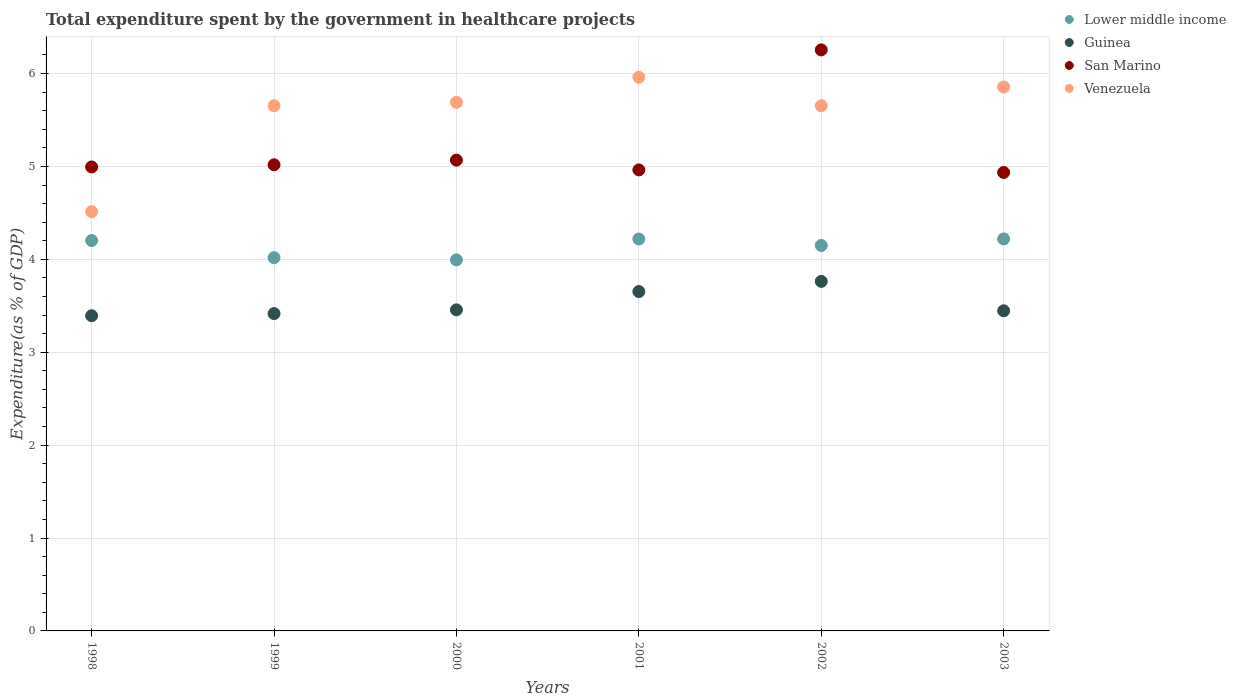How many different coloured dotlines are there?
Provide a succinct answer. 4. What is the total expenditure spent by the government in healthcare projects in Lower middle income in 1999?
Keep it short and to the point. 4.02. Across all years, what is the maximum total expenditure spent by the government in healthcare projects in Venezuela?
Give a very brief answer. 5.96. Across all years, what is the minimum total expenditure spent by the government in healthcare projects in Venezuela?
Your answer should be very brief. 4.51. In which year was the total expenditure spent by the government in healthcare projects in Lower middle income maximum?
Your answer should be compact. 2003. In which year was the total expenditure spent by the government in healthcare projects in San Marino minimum?
Provide a short and direct response. 2003. What is the total total expenditure spent by the government in healthcare projects in Guinea in the graph?
Keep it short and to the point. 21.13. What is the difference between the total expenditure spent by the government in healthcare projects in San Marino in 2001 and that in 2003?
Your answer should be compact. 0.03. What is the difference between the total expenditure spent by the government in healthcare projects in Venezuela in 1998 and the total expenditure spent by the government in healthcare projects in San Marino in 2001?
Offer a very short reply. -0.45. What is the average total expenditure spent by the government in healthcare projects in Lower middle income per year?
Provide a short and direct response. 4.13. In the year 2001, what is the difference between the total expenditure spent by the government in healthcare projects in San Marino and total expenditure spent by the government in healthcare projects in Venezuela?
Provide a short and direct response. -1. What is the ratio of the total expenditure spent by the government in healthcare projects in Guinea in 2002 to that in 2003?
Provide a succinct answer. 1.09. What is the difference between the highest and the second highest total expenditure spent by the government in healthcare projects in Venezuela?
Offer a terse response. 0.1. What is the difference between the highest and the lowest total expenditure spent by the government in healthcare projects in San Marino?
Provide a succinct answer. 1.32. Is it the case that in every year, the sum of the total expenditure spent by the government in healthcare projects in Lower middle income and total expenditure spent by the government in healthcare projects in Venezuela  is greater than the sum of total expenditure spent by the government in healthcare projects in Guinea and total expenditure spent by the government in healthcare projects in San Marino?
Your answer should be very brief. No. Does the total expenditure spent by the government in healthcare projects in San Marino monotonically increase over the years?
Ensure brevity in your answer.  No. Are the values on the major ticks of Y-axis written in scientific E-notation?
Give a very brief answer. No. How are the legend labels stacked?
Your response must be concise. Vertical. What is the title of the graph?
Ensure brevity in your answer.  Total expenditure spent by the government in healthcare projects. What is the label or title of the Y-axis?
Ensure brevity in your answer.  Expenditure(as % of GDP). What is the Expenditure(as % of GDP) of Lower middle income in 1998?
Offer a terse response. 4.2. What is the Expenditure(as % of GDP) of Guinea in 1998?
Your answer should be very brief. 3.39. What is the Expenditure(as % of GDP) of San Marino in 1998?
Your answer should be very brief. 4.99. What is the Expenditure(as % of GDP) in Venezuela in 1998?
Give a very brief answer. 4.51. What is the Expenditure(as % of GDP) in Lower middle income in 1999?
Keep it short and to the point. 4.02. What is the Expenditure(as % of GDP) of Guinea in 1999?
Keep it short and to the point. 3.42. What is the Expenditure(as % of GDP) in San Marino in 1999?
Your answer should be compact. 5.02. What is the Expenditure(as % of GDP) of Venezuela in 1999?
Keep it short and to the point. 5.65. What is the Expenditure(as % of GDP) of Lower middle income in 2000?
Offer a terse response. 3.99. What is the Expenditure(as % of GDP) of Guinea in 2000?
Provide a short and direct response. 3.46. What is the Expenditure(as % of GDP) of San Marino in 2000?
Your response must be concise. 5.07. What is the Expenditure(as % of GDP) in Venezuela in 2000?
Your answer should be very brief. 5.69. What is the Expenditure(as % of GDP) of Lower middle income in 2001?
Offer a terse response. 4.22. What is the Expenditure(as % of GDP) in Guinea in 2001?
Make the answer very short. 3.65. What is the Expenditure(as % of GDP) in San Marino in 2001?
Give a very brief answer. 4.96. What is the Expenditure(as % of GDP) of Venezuela in 2001?
Keep it short and to the point. 5.96. What is the Expenditure(as % of GDP) in Lower middle income in 2002?
Your answer should be very brief. 4.15. What is the Expenditure(as % of GDP) of Guinea in 2002?
Provide a short and direct response. 3.76. What is the Expenditure(as % of GDP) of San Marino in 2002?
Give a very brief answer. 6.25. What is the Expenditure(as % of GDP) of Venezuela in 2002?
Make the answer very short. 5.65. What is the Expenditure(as % of GDP) in Lower middle income in 2003?
Your answer should be very brief. 4.22. What is the Expenditure(as % of GDP) in Guinea in 2003?
Provide a succinct answer. 3.45. What is the Expenditure(as % of GDP) in San Marino in 2003?
Your answer should be compact. 4.94. What is the Expenditure(as % of GDP) in Venezuela in 2003?
Your answer should be compact. 5.86. Across all years, what is the maximum Expenditure(as % of GDP) in Lower middle income?
Ensure brevity in your answer.  4.22. Across all years, what is the maximum Expenditure(as % of GDP) of Guinea?
Offer a terse response. 3.76. Across all years, what is the maximum Expenditure(as % of GDP) of San Marino?
Provide a succinct answer. 6.25. Across all years, what is the maximum Expenditure(as % of GDP) in Venezuela?
Make the answer very short. 5.96. Across all years, what is the minimum Expenditure(as % of GDP) in Lower middle income?
Your answer should be very brief. 3.99. Across all years, what is the minimum Expenditure(as % of GDP) in Guinea?
Provide a succinct answer. 3.39. Across all years, what is the minimum Expenditure(as % of GDP) of San Marino?
Offer a terse response. 4.94. Across all years, what is the minimum Expenditure(as % of GDP) in Venezuela?
Offer a terse response. 4.51. What is the total Expenditure(as % of GDP) of Lower middle income in the graph?
Keep it short and to the point. 24.8. What is the total Expenditure(as % of GDP) in Guinea in the graph?
Your answer should be compact. 21.13. What is the total Expenditure(as % of GDP) in San Marino in the graph?
Ensure brevity in your answer.  31.23. What is the total Expenditure(as % of GDP) of Venezuela in the graph?
Offer a terse response. 33.33. What is the difference between the Expenditure(as % of GDP) in Lower middle income in 1998 and that in 1999?
Offer a very short reply. 0.18. What is the difference between the Expenditure(as % of GDP) in Guinea in 1998 and that in 1999?
Give a very brief answer. -0.02. What is the difference between the Expenditure(as % of GDP) of San Marino in 1998 and that in 1999?
Your response must be concise. -0.02. What is the difference between the Expenditure(as % of GDP) of Venezuela in 1998 and that in 1999?
Keep it short and to the point. -1.14. What is the difference between the Expenditure(as % of GDP) of Lower middle income in 1998 and that in 2000?
Make the answer very short. 0.21. What is the difference between the Expenditure(as % of GDP) in Guinea in 1998 and that in 2000?
Give a very brief answer. -0.06. What is the difference between the Expenditure(as % of GDP) in San Marino in 1998 and that in 2000?
Your answer should be compact. -0.07. What is the difference between the Expenditure(as % of GDP) of Venezuela in 1998 and that in 2000?
Make the answer very short. -1.18. What is the difference between the Expenditure(as % of GDP) in Lower middle income in 1998 and that in 2001?
Your response must be concise. -0.02. What is the difference between the Expenditure(as % of GDP) in Guinea in 1998 and that in 2001?
Your answer should be very brief. -0.26. What is the difference between the Expenditure(as % of GDP) in San Marino in 1998 and that in 2001?
Provide a succinct answer. 0.03. What is the difference between the Expenditure(as % of GDP) of Venezuela in 1998 and that in 2001?
Provide a short and direct response. -1.45. What is the difference between the Expenditure(as % of GDP) of Lower middle income in 1998 and that in 2002?
Ensure brevity in your answer.  0.05. What is the difference between the Expenditure(as % of GDP) in Guinea in 1998 and that in 2002?
Offer a terse response. -0.37. What is the difference between the Expenditure(as % of GDP) in San Marino in 1998 and that in 2002?
Your response must be concise. -1.26. What is the difference between the Expenditure(as % of GDP) of Venezuela in 1998 and that in 2002?
Your answer should be very brief. -1.14. What is the difference between the Expenditure(as % of GDP) of Lower middle income in 1998 and that in 2003?
Your response must be concise. -0.02. What is the difference between the Expenditure(as % of GDP) in Guinea in 1998 and that in 2003?
Make the answer very short. -0.05. What is the difference between the Expenditure(as % of GDP) of San Marino in 1998 and that in 2003?
Give a very brief answer. 0.06. What is the difference between the Expenditure(as % of GDP) in Venezuela in 1998 and that in 2003?
Offer a terse response. -1.34. What is the difference between the Expenditure(as % of GDP) in Lower middle income in 1999 and that in 2000?
Offer a very short reply. 0.02. What is the difference between the Expenditure(as % of GDP) of Guinea in 1999 and that in 2000?
Your answer should be compact. -0.04. What is the difference between the Expenditure(as % of GDP) in San Marino in 1999 and that in 2000?
Make the answer very short. -0.05. What is the difference between the Expenditure(as % of GDP) of Venezuela in 1999 and that in 2000?
Provide a succinct answer. -0.04. What is the difference between the Expenditure(as % of GDP) of Lower middle income in 1999 and that in 2001?
Offer a terse response. -0.2. What is the difference between the Expenditure(as % of GDP) of Guinea in 1999 and that in 2001?
Provide a succinct answer. -0.24. What is the difference between the Expenditure(as % of GDP) of San Marino in 1999 and that in 2001?
Offer a very short reply. 0.06. What is the difference between the Expenditure(as % of GDP) of Venezuela in 1999 and that in 2001?
Keep it short and to the point. -0.31. What is the difference between the Expenditure(as % of GDP) of Lower middle income in 1999 and that in 2002?
Give a very brief answer. -0.13. What is the difference between the Expenditure(as % of GDP) in Guinea in 1999 and that in 2002?
Offer a very short reply. -0.35. What is the difference between the Expenditure(as % of GDP) in San Marino in 1999 and that in 2002?
Give a very brief answer. -1.24. What is the difference between the Expenditure(as % of GDP) of Venezuela in 1999 and that in 2002?
Ensure brevity in your answer.  -0. What is the difference between the Expenditure(as % of GDP) of Lower middle income in 1999 and that in 2003?
Provide a succinct answer. -0.2. What is the difference between the Expenditure(as % of GDP) of Guinea in 1999 and that in 2003?
Make the answer very short. -0.03. What is the difference between the Expenditure(as % of GDP) of San Marino in 1999 and that in 2003?
Your answer should be compact. 0.08. What is the difference between the Expenditure(as % of GDP) in Venezuela in 1999 and that in 2003?
Provide a short and direct response. -0.2. What is the difference between the Expenditure(as % of GDP) of Lower middle income in 2000 and that in 2001?
Provide a short and direct response. -0.23. What is the difference between the Expenditure(as % of GDP) of Guinea in 2000 and that in 2001?
Your answer should be compact. -0.2. What is the difference between the Expenditure(as % of GDP) in San Marino in 2000 and that in 2001?
Provide a short and direct response. 0.11. What is the difference between the Expenditure(as % of GDP) in Venezuela in 2000 and that in 2001?
Offer a terse response. -0.27. What is the difference between the Expenditure(as % of GDP) of Lower middle income in 2000 and that in 2002?
Offer a terse response. -0.16. What is the difference between the Expenditure(as % of GDP) in Guinea in 2000 and that in 2002?
Your response must be concise. -0.31. What is the difference between the Expenditure(as % of GDP) of San Marino in 2000 and that in 2002?
Provide a succinct answer. -1.19. What is the difference between the Expenditure(as % of GDP) in Venezuela in 2000 and that in 2002?
Your answer should be very brief. 0.04. What is the difference between the Expenditure(as % of GDP) of Lower middle income in 2000 and that in 2003?
Make the answer very short. -0.23. What is the difference between the Expenditure(as % of GDP) in Guinea in 2000 and that in 2003?
Give a very brief answer. 0.01. What is the difference between the Expenditure(as % of GDP) of San Marino in 2000 and that in 2003?
Make the answer very short. 0.13. What is the difference between the Expenditure(as % of GDP) in Venezuela in 2000 and that in 2003?
Your response must be concise. -0.16. What is the difference between the Expenditure(as % of GDP) in Lower middle income in 2001 and that in 2002?
Offer a terse response. 0.07. What is the difference between the Expenditure(as % of GDP) of Guinea in 2001 and that in 2002?
Your answer should be very brief. -0.11. What is the difference between the Expenditure(as % of GDP) in San Marino in 2001 and that in 2002?
Your answer should be very brief. -1.29. What is the difference between the Expenditure(as % of GDP) in Venezuela in 2001 and that in 2002?
Offer a very short reply. 0.31. What is the difference between the Expenditure(as % of GDP) of Lower middle income in 2001 and that in 2003?
Provide a short and direct response. -0. What is the difference between the Expenditure(as % of GDP) of Guinea in 2001 and that in 2003?
Your answer should be compact. 0.21. What is the difference between the Expenditure(as % of GDP) of San Marino in 2001 and that in 2003?
Ensure brevity in your answer.  0.03. What is the difference between the Expenditure(as % of GDP) of Venezuela in 2001 and that in 2003?
Provide a succinct answer. 0.1. What is the difference between the Expenditure(as % of GDP) in Lower middle income in 2002 and that in 2003?
Provide a succinct answer. -0.07. What is the difference between the Expenditure(as % of GDP) in Guinea in 2002 and that in 2003?
Provide a succinct answer. 0.32. What is the difference between the Expenditure(as % of GDP) of San Marino in 2002 and that in 2003?
Give a very brief answer. 1.32. What is the difference between the Expenditure(as % of GDP) in Venezuela in 2002 and that in 2003?
Provide a succinct answer. -0.2. What is the difference between the Expenditure(as % of GDP) in Lower middle income in 1998 and the Expenditure(as % of GDP) in Guinea in 1999?
Give a very brief answer. 0.79. What is the difference between the Expenditure(as % of GDP) in Lower middle income in 1998 and the Expenditure(as % of GDP) in San Marino in 1999?
Make the answer very short. -0.82. What is the difference between the Expenditure(as % of GDP) in Lower middle income in 1998 and the Expenditure(as % of GDP) in Venezuela in 1999?
Your response must be concise. -1.45. What is the difference between the Expenditure(as % of GDP) in Guinea in 1998 and the Expenditure(as % of GDP) in San Marino in 1999?
Provide a succinct answer. -1.62. What is the difference between the Expenditure(as % of GDP) of Guinea in 1998 and the Expenditure(as % of GDP) of Venezuela in 1999?
Offer a terse response. -2.26. What is the difference between the Expenditure(as % of GDP) of San Marino in 1998 and the Expenditure(as % of GDP) of Venezuela in 1999?
Offer a terse response. -0.66. What is the difference between the Expenditure(as % of GDP) in Lower middle income in 1998 and the Expenditure(as % of GDP) in Guinea in 2000?
Your response must be concise. 0.75. What is the difference between the Expenditure(as % of GDP) in Lower middle income in 1998 and the Expenditure(as % of GDP) in San Marino in 2000?
Your response must be concise. -0.87. What is the difference between the Expenditure(as % of GDP) in Lower middle income in 1998 and the Expenditure(as % of GDP) in Venezuela in 2000?
Keep it short and to the point. -1.49. What is the difference between the Expenditure(as % of GDP) of Guinea in 1998 and the Expenditure(as % of GDP) of San Marino in 2000?
Ensure brevity in your answer.  -1.68. What is the difference between the Expenditure(as % of GDP) of Guinea in 1998 and the Expenditure(as % of GDP) of Venezuela in 2000?
Provide a succinct answer. -2.3. What is the difference between the Expenditure(as % of GDP) of San Marino in 1998 and the Expenditure(as % of GDP) of Venezuela in 2000?
Your answer should be compact. -0.7. What is the difference between the Expenditure(as % of GDP) of Lower middle income in 1998 and the Expenditure(as % of GDP) of Guinea in 2001?
Give a very brief answer. 0.55. What is the difference between the Expenditure(as % of GDP) of Lower middle income in 1998 and the Expenditure(as % of GDP) of San Marino in 2001?
Offer a very short reply. -0.76. What is the difference between the Expenditure(as % of GDP) in Lower middle income in 1998 and the Expenditure(as % of GDP) in Venezuela in 2001?
Your answer should be very brief. -1.76. What is the difference between the Expenditure(as % of GDP) of Guinea in 1998 and the Expenditure(as % of GDP) of San Marino in 2001?
Make the answer very short. -1.57. What is the difference between the Expenditure(as % of GDP) in Guinea in 1998 and the Expenditure(as % of GDP) in Venezuela in 2001?
Make the answer very short. -2.57. What is the difference between the Expenditure(as % of GDP) of San Marino in 1998 and the Expenditure(as % of GDP) of Venezuela in 2001?
Ensure brevity in your answer.  -0.97. What is the difference between the Expenditure(as % of GDP) in Lower middle income in 1998 and the Expenditure(as % of GDP) in Guinea in 2002?
Give a very brief answer. 0.44. What is the difference between the Expenditure(as % of GDP) of Lower middle income in 1998 and the Expenditure(as % of GDP) of San Marino in 2002?
Keep it short and to the point. -2.05. What is the difference between the Expenditure(as % of GDP) of Lower middle income in 1998 and the Expenditure(as % of GDP) of Venezuela in 2002?
Ensure brevity in your answer.  -1.45. What is the difference between the Expenditure(as % of GDP) of Guinea in 1998 and the Expenditure(as % of GDP) of San Marino in 2002?
Make the answer very short. -2.86. What is the difference between the Expenditure(as % of GDP) of Guinea in 1998 and the Expenditure(as % of GDP) of Venezuela in 2002?
Offer a very short reply. -2.26. What is the difference between the Expenditure(as % of GDP) in San Marino in 1998 and the Expenditure(as % of GDP) in Venezuela in 2002?
Provide a short and direct response. -0.66. What is the difference between the Expenditure(as % of GDP) of Lower middle income in 1998 and the Expenditure(as % of GDP) of Guinea in 2003?
Keep it short and to the point. 0.76. What is the difference between the Expenditure(as % of GDP) of Lower middle income in 1998 and the Expenditure(as % of GDP) of San Marino in 2003?
Your answer should be very brief. -0.73. What is the difference between the Expenditure(as % of GDP) of Lower middle income in 1998 and the Expenditure(as % of GDP) of Venezuela in 2003?
Your answer should be very brief. -1.65. What is the difference between the Expenditure(as % of GDP) in Guinea in 1998 and the Expenditure(as % of GDP) in San Marino in 2003?
Make the answer very short. -1.54. What is the difference between the Expenditure(as % of GDP) in Guinea in 1998 and the Expenditure(as % of GDP) in Venezuela in 2003?
Provide a succinct answer. -2.46. What is the difference between the Expenditure(as % of GDP) in San Marino in 1998 and the Expenditure(as % of GDP) in Venezuela in 2003?
Keep it short and to the point. -0.86. What is the difference between the Expenditure(as % of GDP) in Lower middle income in 1999 and the Expenditure(as % of GDP) in Guinea in 2000?
Your answer should be compact. 0.56. What is the difference between the Expenditure(as % of GDP) in Lower middle income in 1999 and the Expenditure(as % of GDP) in San Marino in 2000?
Your answer should be compact. -1.05. What is the difference between the Expenditure(as % of GDP) of Lower middle income in 1999 and the Expenditure(as % of GDP) of Venezuela in 2000?
Your response must be concise. -1.67. What is the difference between the Expenditure(as % of GDP) of Guinea in 1999 and the Expenditure(as % of GDP) of San Marino in 2000?
Your response must be concise. -1.65. What is the difference between the Expenditure(as % of GDP) of Guinea in 1999 and the Expenditure(as % of GDP) of Venezuela in 2000?
Ensure brevity in your answer.  -2.27. What is the difference between the Expenditure(as % of GDP) in San Marino in 1999 and the Expenditure(as % of GDP) in Venezuela in 2000?
Offer a very short reply. -0.67. What is the difference between the Expenditure(as % of GDP) of Lower middle income in 1999 and the Expenditure(as % of GDP) of Guinea in 2001?
Your response must be concise. 0.36. What is the difference between the Expenditure(as % of GDP) in Lower middle income in 1999 and the Expenditure(as % of GDP) in San Marino in 2001?
Keep it short and to the point. -0.94. What is the difference between the Expenditure(as % of GDP) of Lower middle income in 1999 and the Expenditure(as % of GDP) of Venezuela in 2001?
Provide a succinct answer. -1.94. What is the difference between the Expenditure(as % of GDP) in Guinea in 1999 and the Expenditure(as % of GDP) in San Marino in 2001?
Your answer should be compact. -1.55. What is the difference between the Expenditure(as % of GDP) of Guinea in 1999 and the Expenditure(as % of GDP) of Venezuela in 2001?
Offer a terse response. -2.54. What is the difference between the Expenditure(as % of GDP) in San Marino in 1999 and the Expenditure(as % of GDP) in Venezuela in 2001?
Offer a very short reply. -0.94. What is the difference between the Expenditure(as % of GDP) of Lower middle income in 1999 and the Expenditure(as % of GDP) of Guinea in 2002?
Keep it short and to the point. 0.26. What is the difference between the Expenditure(as % of GDP) of Lower middle income in 1999 and the Expenditure(as % of GDP) of San Marino in 2002?
Your answer should be compact. -2.24. What is the difference between the Expenditure(as % of GDP) of Lower middle income in 1999 and the Expenditure(as % of GDP) of Venezuela in 2002?
Provide a short and direct response. -1.64. What is the difference between the Expenditure(as % of GDP) of Guinea in 1999 and the Expenditure(as % of GDP) of San Marino in 2002?
Your response must be concise. -2.84. What is the difference between the Expenditure(as % of GDP) of Guinea in 1999 and the Expenditure(as % of GDP) of Venezuela in 2002?
Offer a very short reply. -2.24. What is the difference between the Expenditure(as % of GDP) in San Marino in 1999 and the Expenditure(as % of GDP) in Venezuela in 2002?
Your response must be concise. -0.64. What is the difference between the Expenditure(as % of GDP) of Lower middle income in 1999 and the Expenditure(as % of GDP) of Guinea in 2003?
Your answer should be compact. 0.57. What is the difference between the Expenditure(as % of GDP) of Lower middle income in 1999 and the Expenditure(as % of GDP) of San Marino in 2003?
Make the answer very short. -0.92. What is the difference between the Expenditure(as % of GDP) in Lower middle income in 1999 and the Expenditure(as % of GDP) in Venezuela in 2003?
Provide a short and direct response. -1.84. What is the difference between the Expenditure(as % of GDP) in Guinea in 1999 and the Expenditure(as % of GDP) in San Marino in 2003?
Keep it short and to the point. -1.52. What is the difference between the Expenditure(as % of GDP) in Guinea in 1999 and the Expenditure(as % of GDP) in Venezuela in 2003?
Your answer should be compact. -2.44. What is the difference between the Expenditure(as % of GDP) of San Marino in 1999 and the Expenditure(as % of GDP) of Venezuela in 2003?
Provide a succinct answer. -0.84. What is the difference between the Expenditure(as % of GDP) of Lower middle income in 2000 and the Expenditure(as % of GDP) of Guinea in 2001?
Offer a terse response. 0.34. What is the difference between the Expenditure(as % of GDP) in Lower middle income in 2000 and the Expenditure(as % of GDP) in San Marino in 2001?
Your response must be concise. -0.97. What is the difference between the Expenditure(as % of GDP) in Lower middle income in 2000 and the Expenditure(as % of GDP) in Venezuela in 2001?
Give a very brief answer. -1.97. What is the difference between the Expenditure(as % of GDP) in Guinea in 2000 and the Expenditure(as % of GDP) in San Marino in 2001?
Your response must be concise. -1.51. What is the difference between the Expenditure(as % of GDP) in Guinea in 2000 and the Expenditure(as % of GDP) in Venezuela in 2001?
Your answer should be compact. -2.5. What is the difference between the Expenditure(as % of GDP) in San Marino in 2000 and the Expenditure(as % of GDP) in Venezuela in 2001?
Offer a terse response. -0.89. What is the difference between the Expenditure(as % of GDP) in Lower middle income in 2000 and the Expenditure(as % of GDP) in Guinea in 2002?
Your answer should be very brief. 0.23. What is the difference between the Expenditure(as % of GDP) of Lower middle income in 2000 and the Expenditure(as % of GDP) of San Marino in 2002?
Offer a terse response. -2.26. What is the difference between the Expenditure(as % of GDP) in Lower middle income in 2000 and the Expenditure(as % of GDP) in Venezuela in 2002?
Your answer should be compact. -1.66. What is the difference between the Expenditure(as % of GDP) of Guinea in 2000 and the Expenditure(as % of GDP) of San Marino in 2002?
Provide a succinct answer. -2.8. What is the difference between the Expenditure(as % of GDP) in Guinea in 2000 and the Expenditure(as % of GDP) in Venezuela in 2002?
Make the answer very short. -2.2. What is the difference between the Expenditure(as % of GDP) of San Marino in 2000 and the Expenditure(as % of GDP) of Venezuela in 2002?
Your answer should be very brief. -0.59. What is the difference between the Expenditure(as % of GDP) in Lower middle income in 2000 and the Expenditure(as % of GDP) in Guinea in 2003?
Offer a terse response. 0.55. What is the difference between the Expenditure(as % of GDP) of Lower middle income in 2000 and the Expenditure(as % of GDP) of San Marino in 2003?
Make the answer very short. -0.94. What is the difference between the Expenditure(as % of GDP) in Lower middle income in 2000 and the Expenditure(as % of GDP) in Venezuela in 2003?
Ensure brevity in your answer.  -1.86. What is the difference between the Expenditure(as % of GDP) of Guinea in 2000 and the Expenditure(as % of GDP) of San Marino in 2003?
Provide a succinct answer. -1.48. What is the difference between the Expenditure(as % of GDP) of Guinea in 2000 and the Expenditure(as % of GDP) of Venezuela in 2003?
Ensure brevity in your answer.  -2.4. What is the difference between the Expenditure(as % of GDP) of San Marino in 2000 and the Expenditure(as % of GDP) of Venezuela in 2003?
Offer a terse response. -0.79. What is the difference between the Expenditure(as % of GDP) of Lower middle income in 2001 and the Expenditure(as % of GDP) of Guinea in 2002?
Provide a succinct answer. 0.46. What is the difference between the Expenditure(as % of GDP) of Lower middle income in 2001 and the Expenditure(as % of GDP) of San Marino in 2002?
Ensure brevity in your answer.  -2.04. What is the difference between the Expenditure(as % of GDP) of Lower middle income in 2001 and the Expenditure(as % of GDP) of Venezuela in 2002?
Ensure brevity in your answer.  -1.43. What is the difference between the Expenditure(as % of GDP) in Guinea in 2001 and the Expenditure(as % of GDP) in San Marino in 2002?
Your answer should be compact. -2.6. What is the difference between the Expenditure(as % of GDP) in Guinea in 2001 and the Expenditure(as % of GDP) in Venezuela in 2002?
Give a very brief answer. -2. What is the difference between the Expenditure(as % of GDP) in San Marino in 2001 and the Expenditure(as % of GDP) in Venezuela in 2002?
Provide a succinct answer. -0.69. What is the difference between the Expenditure(as % of GDP) of Lower middle income in 2001 and the Expenditure(as % of GDP) of Guinea in 2003?
Make the answer very short. 0.77. What is the difference between the Expenditure(as % of GDP) of Lower middle income in 2001 and the Expenditure(as % of GDP) of San Marino in 2003?
Give a very brief answer. -0.72. What is the difference between the Expenditure(as % of GDP) in Lower middle income in 2001 and the Expenditure(as % of GDP) in Venezuela in 2003?
Make the answer very short. -1.64. What is the difference between the Expenditure(as % of GDP) in Guinea in 2001 and the Expenditure(as % of GDP) in San Marino in 2003?
Offer a very short reply. -1.28. What is the difference between the Expenditure(as % of GDP) of Guinea in 2001 and the Expenditure(as % of GDP) of Venezuela in 2003?
Your answer should be compact. -2.2. What is the difference between the Expenditure(as % of GDP) of San Marino in 2001 and the Expenditure(as % of GDP) of Venezuela in 2003?
Offer a terse response. -0.89. What is the difference between the Expenditure(as % of GDP) in Lower middle income in 2002 and the Expenditure(as % of GDP) in Guinea in 2003?
Ensure brevity in your answer.  0.7. What is the difference between the Expenditure(as % of GDP) of Lower middle income in 2002 and the Expenditure(as % of GDP) of San Marino in 2003?
Ensure brevity in your answer.  -0.79. What is the difference between the Expenditure(as % of GDP) of Lower middle income in 2002 and the Expenditure(as % of GDP) of Venezuela in 2003?
Your answer should be very brief. -1.71. What is the difference between the Expenditure(as % of GDP) in Guinea in 2002 and the Expenditure(as % of GDP) in San Marino in 2003?
Offer a terse response. -1.17. What is the difference between the Expenditure(as % of GDP) of Guinea in 2002 and the Expenditure(as % of GDP) of Venezuela in 2003?
Make the answer very short. -2.09. What is the difference between the Expenditure(as % of GDP) in San Marino in 2002 and the Expenditure(as % of GDP) in Venezuela in 2003?
Provide a short and direct response. 0.4. What is the average Expenditure(as % of GDP) of Lower middle income per year?
Provide a succinct answer. 4.13. What is the average Expenditure(as % of GDP) in Guinea per year?
Your response must be concise. 3.52. What is the average Expenditure(as % of GDP) of San Marino per year?
Ensure brevity in your answer.  5.21. What is the average Expenditure(as % of GDP) in Venezuela per year?
Offer a very short reply. 5.55. In the year 1998, what is the difference between the Expenditure(as % of GDP) in Lower middle income and Expenditure(as % of GDP) in Guinea?
Your answer should be very brief. 0.81. In the year 1998, what is the difference between the Expenditure(as % of GDP) in Lower middle income and Expenditure(as % of GDP) in San Marino?
Your response must be concise. -0.79. In the year 1998, what is the difference between the Expenditure(as % of GDP) of Lower middle income and Expenditure(as % of GDP) of Venezuela?
Give a very brief answer. -0.31. In the year 1998, what is the difference between the Expenditure(as % of GDP) in Guinea and Expenditure(as % of GDP) in San Marino?
Provide a short and direct response. -1.6. In the year 1998, what is the difference between the Expenditure(as % of GDP) in Guinea and Expenditure(as % of GDP) in Venezuela?
Provide a succinct answer. -1.12. In the year 1998, what is the difference between the Expenditure(as % of GDP) in San Marino and Expenditure(as % of GDP) in Venezuela?
Make the answer very short. 0.48. In the year 1999, what is the difference between the Expenditure(as % of GDP) of Lower middle income and Expenditure(as % of GDP) of Guinea?
Your answer should be very brief. 0.6. In the year 1999, what is the difference between the Expenditure(as % of GDP) of Lower middle income and Expenditure(as % of GDP) of San Marino?
Your response must be concise. -1. In the year 1999, what is the difference between the Expenditure(as % of GDP) in Lower middle income and Expenditure(as % of GDP) in Venezuela?
Keep it short and to the point. -1.64. In the year 1999, what is the difference between the Expenditure(as % of GDP) of Guinea and Expenditure(as % of GDP) of San Marino?
Ensure brevity in your answer.  -1.6. In the year 1999, what is the difference between the Expenditure(as % of GDP) in Guinea and Expenditure(as % of GDP) in Venezuela?
Make the answer very short. -2.24. In the year 1999, what is the difference between the Expenditure(as % of GDP) in San Marino and Expenditure(as % of GDP) in Venezuela?
Your answer should be very brief. -0.64. In the year 2000, what is the difference between the Expenditure(as % of GDP) in Lower middle income and Expenditure(as % of GDP) in Guinea?
Offer a very short reply. 0.54. In the year 2000, what is the difference between the Expenditure(as % of GDP) of Lower middle income and Expenditure(as % of GDP) of San Marino?
Keep it short and to the point. -1.07. In the year 2000, what is the difference between the Expenditure(as % of GDP) in Lower middle income and Expenditure(as % of GDP) in Venezuela?
Your response must be concise. -1.7. In the year 2000, what is the difference between the Expenditure(as % of GDP) in Guinea and Expenditure(as % of GDP) in San Marino?
Offer a terse response. -1.61. In the year 2000, what is the difference between the Expenditure(as % of GDP) in Guinea and Expenditure(as % of GDP) in Venezuela?
Provide a short and direct response. -2.23. In the year 2000, what is the difference between the Expenditure(as % of GDP) of San Marino and Expenditure(as % of GDP) of Venezuela?
Make the answer very short. -0.62. In the year 2001, what is the difference between the Expenditure(as % of GDP) in Lower middle income and Expenditure(as % of GDP) in Guinea?
Your answer should be very brief. 0.57. In the year 2001, what is the difference between the Expenditure(as % of GDP) of Lower middle income and Expenditure(as % of GDP) of San Marino?
Your response must be concise. -0.74. In the year 2001, what is the difference between the Expenditure(as % of GDP) in Lower middle income and Expenditure(as % of GDP) in Venezuela?
Make the answer very short. -1.74. In the year 2001, what is the difference between the Expenditure(as % of GDP) of Guinea and Expenditure(as % of GDP) of San Marino?
Give a very brief answer. -1.31. In the year 2001, what is the difference between the Expenditure(as % of GDP) of Guinea and Expenditure(as % of GDP) of Venezuela?
Make the answer very short. -2.31. In the year 2001, what is the difference between the Expenditure(as % of GDP) in San Marino and Expenditure(as % of GDP) in Venezuela?
Keep it short and to the point. -1. In the year 2002, what is the difference between the Expenditure(as % of GDP) in Lower middle income and Expenditure(as % of GDP) in Guinea?
Provide a succinct answer. 0.39. In the year 2002, what is the difference between the Expenditure(as % of GDP) of Lower middle income and Expenditure(as % of GDP) of San Marino?
Offer a very short reply. -2.11. In the year 2002, what is the difference between the Expenditure(as % of GDP) in Lower middle income and Expenditure(as % of GDP) in Venezuela?
Give a very brief answer. -1.5. In the year 2002, what is the difference between the Expenditure(as % of GDP) of Guinea and Expenditure(as % of GDP) of San Marino?
Keep it short and to the point. -2.49. In the year 2002, what is the difference between the Expenditure(as % of GDP) of Guinea and Expenditure(as % of GDP) of Venezuela?
Ensure brevity in your answer.  -1.89. In the year 2002, what is the difference between the Expenditure(as % of GDP) of San Marino and Expenditure(as % of GDP) of Venezuela?
Offer a terse response. 0.6. In the year 2003, what is the difference between the Expenditure(as % of GDP) of Lower middle income and Expenditure(as % of GDP) of Guinea?
Ensure brevity in your answer.  0.77. In the year 2003, what is the difference between the Expenditure(as % of GDP) of Lower middle income and Expenditure(as % of GDP) of San Marino?
Your answer should be compact. -0.72. In the year 2003, what is the difference between the Expenditure(as % of GDP) of Lower middle income and Expenditure(as % of GDP) of Venezuela?
Ensure brevity in your answer.  -1.64. In the year 2003, what is the difference between the Expenditure(as % of GDP) of Guinea and Expenditure(as % of GDP) of San Marino?
Ensure brevity in your answer.  -1.49. In the year 2003, what is the difference between the Expenditure(as % of GDP) in Guinea and Expenditure(as % of GDP) in Venezuela?
Your response must be concise. -2.41. In the year 2003, what is the difference between the Expenditure(as % of GDP) of San Marino and Expenditure(as % of GDP) of Venezuela?
Your response must be concise. -0.92. What is the ratio of the Expenditure(as % of GDP) in Lower middle income in 1998 to that in 1999?
Make the answer very short. 1.05. What is the ratio of the Expenditure(as % of GDP) in San Marino in 1998 to that in 1999?
Offer a terse response. 1. What is the ratio of the Expenditure(as % of GDP) in Venezuela in 1998 to that in 1999?
Offer a terse response. 0.8. What is the ratio of the Expenditure(as % of GDP) in Lower middle income in 1998 to that in 2000?
Provide a short and direct response. 1.05. What is the ratio of the Expenditure(as % of GDP) in Guinea in 1998 to that in 2000?
Make the answer very short. 0.98. What is the ratio of the Expenditure(as % of GDP) of San Marino in 1998 to that in 2000?
Give a very brief answer. 0.99. What is the ratio of the Expenditure(as % of GDP) of Venezuela in 1998 to that in 2000?
Your answer should be very brief. 0.79. What is the ratio of the Expenditure(as % of GDP) in Guinea in 1998 to that in 2001?
Provide a short and direct response. 0.93. What is the ratio of the Expenditure(as % of GDP) in San Marino in 1998 to that in 2001?
Ensure brevity in your answer.  1.01. What is the ratio of the Expenditure(as % of GDP) of Venezuela in 1998 to that in 2001?
Ensure brevity in your answer.  0.76. What is the ratio of the Expenditure(as % of GDP) of Lower middle income in 1998 to that in 2002?
Provide a succinct answer. 1.01. What is the ratio of the Expenditure(as % of GDP) in Guinea in 1998 to that in 2002?
Make the answer very short. 0.9. What is the ratio of the Expenditure(as % of GDP) of San Marino in 1998 to that in 2002?
Offer a terse response. 0.8. What is the ratio of the Expenditure(as % of GDP) in Venezuela in 1998 to that in 2002?
Your answer should be compact. 0.8. What is the ratio of the Expenditure(as % of GDP) in Lower middle income in 1998 to that in 2003?
Your answer should be compact. 1. What is the ratio of the Expenditure(as % of GDP) of Guinea in 1998 to that in 2003?
Your answer should be very brief. 0.98. What is the ratio of the Expenditure(as % of GDP) of Venezuela in 1998 to that in 2003?
Offer a terse response. 0.77. What is the ratio of the Expenditure(as % of GDP) of Lower middle income in 1999 to that in 2000?
Ensure brevity in your answer.  1.01. What is the ratio of the Expenditure(as % of GDP) in Guinea in 1999 to that in 2000?
Give a very brief answer. 0.99. What is the ratio of the Expenditure(as % of GDP) of Lower middle income in 1999 to that in 2001?
Ensure brevity in your answer.  0.95. What is the ratio of the Expenditure(as % of GDP) of Guinea in 1999 to that in 2001?
Keep it short and to the point. 0.94. What is the ratio of the Expenditure(as % of GDP) of San Marino in 1999 to that in 2001?
Provide a short and direct response. 1.01. What is the ratio of the Expenditure(as % of GDP) in Venezuela in 1999 to that in 2001?
Offer a very short reply. 0.95. What is the ratio of the Expenditure(as % of GDP) of Lower middle income in 1999 to that in 2002?
Make the answer very short. 0.97. What is the ratio of the Expenditure(as % of GDP) in Guinea in 1999 to that in 2002?
Provide a short and direct response. 0.91. What is the ratio of the Expenditure(as % of GDP) in San Marino in 1999 to that in 2002?
Your answer should be compact. 0.8. What is the ratio of the Expenditure(as % of GDP) in Venezuela in 1999 to that in 2002?
Offer a very short reply. 1. What is the ratio of the Expenditure(as % of GDP) in Lower middle income in 1999 to that in 2003?
Keep it short and to the point. 0.95. What is the ratio of the Expenditure(as % of GDP) of Guinea in 1999 to that in 2003?
Provide a short and direct response. 0.99. What is the ratio of the Expenditure(as % of GDP) of San Marino in 1999 to that in 2003?
Ensure brevity in your answer.  1.02. What is the ratio of the Expenditure(as % of GDP) in Venezuela in 1999 to that in 2003?
Provide a short and direct response. 0.97. What is the ratio of the Expenditure(as % of GDP) of Lower middle income in 2000 to that in 2001?
Ensure brevity in your answer.  0.95. What is the ratio of the Expenditure(as % of GDP) in Guinea in 2000 to that in 2001?
Your answer should be very brief. 0.95. What is the ratio of the Expenditure(as % of GDP) of San Marino in 2000 to that in 2001?
Ensure brevity in your answer.  1.02. What is the ratio of the Expenditure(as % of GDP) in Venezuela in 2000 to that in 2001?
Make the answer very short. 0.95. What is the ratio of the Expenditure(as % of GDP) of Lower middle income in 2000 to that in 2002?
Ensure brevity in your answer.  0.96. What is the ratio of the Expenditure(as % of GDP) of Guinea in 2000 to that in 2002?
Offer a very short reply. 0.92. What is the ratio of the Expenditure(as % of GDP) in San Marino in 2000 to that in 2002?
Provide a short and direct response. 0.81. What is the ratio of the Expenditure(as % of GDP) in Venezuela in 2000 to that in 2002?
Give a very brief answer. 1.01. What is the ratio of the Expenditure(as % of GDP) in Lower middle income in 2000 to that in 2003?
Provide a succinct answer. 0.95. What is the ratio of the Expenditure(as % of GDP) of San Marino in 2000 to that in 2003?
Provide a short and direct response. 1.03. What is the ratio of the Expenditure(as % of GDP) in Venezuela in 2000 to that in 2003?
Make the answer very short. 0.97. What is the ratio of the Expenditure(as % of GDP) of Lower middle income in 2001 to that in 2002?
Your answer should be compact. 1.02. What is the ratio of the Expenditure(as % of GDP) of San Marino in 2001 to that in 2002?
Your answer should be compact. 0.79. What is the ratio of the Expenditure(as % of GDP) of Venezuela in 2001 to that in 2002?
Make the answer very short. 1.05. What is the ratio of the Expenditure(as % of GDP) in Lower middle income in 2001 to that in 2003?
Provide a short and direct response. 1. What is the ratio of the Expenditure(as % of GDP) of Guinea in 2001 to that in 2003?
Provide a short and direct response. 1.06. What is the ratio of the Expenditure(as % of GDP) in San Marino in 2001 to that in 2003?
Keep it short and to the point. 1.01. What is the ratio of the Expenditure(as % of GDP) in Venezuela in 2001 to that in 2003?
Keep it short and to the point. 1.02. What is the ratio of the Expenditure(as % of GDP) in Lower middle income in 2002 to that in 2003?
Provide a succinct answer. 0.98. What is the ratio of the Expenditure(as % of GDP) in Guinea in 2002 to that in 2003?
Offer a terse response. 1.09. What is the ratio of the Expenditure(as % of GDP) in San Marino in 2002 to that in 2003?
Your answer should be very brief. 1.27. What is the ratio of the Expenditure(as % of GDP) of Venezuela in 2002 to that in 2003?
Provide a short and direct response. 0.97. What is the difference between the highest and the second highest Expenditure(as % of GDP) of Lower middle income?
Your response must be concise. 0. What is the difference between the highest and the second highest Expenditure(as % of GDP) of Guinea?
Keep it short and to the point. 0.11. What is the difference between the highest and the second highest Expenditure(as % of GDP) of San Marino?
Your answer should be very brief. 1.19. What is the difference between the highest and the second highest Expenditure(as % of GDP) of Venezuela?
Your answer should be very brief. 0.1. What is the difference between the highest and the lowest Expenditure(as % of GDP) of Lower middle income?
Provide a short and direct response. 0.23. What is the difference between the highest and the lowest Expenditure(as % of GDP) in Guinea?
Keep it short and to the point. 0.37. What is the difference between the highest and the lowest Expenditure(as % of GDP) in San Marino?
Your response must be concise. 1.32. What is the difference between the highest and the lowest Expenditure(as % of GDP) of Venezuela?
Make the answer very short. 1.45. 